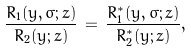Convert formula to latex. <formula><loc_0><loc_0><loc_500><loc_500>\frac { R _ { 1 } ( y , \sigma ; z ) } { R _ { 2 } ( y ; z ) } \, = \, \frac { R ^ { * } _ { 1 } ( y , \sigma ; z ) } { R ^ { * } _ { 2 } ( y ; z ) } ,</formula> 